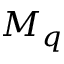<formula> <loc_0><loc_0><loc_500><loc_500>M _ { q }</formula> 